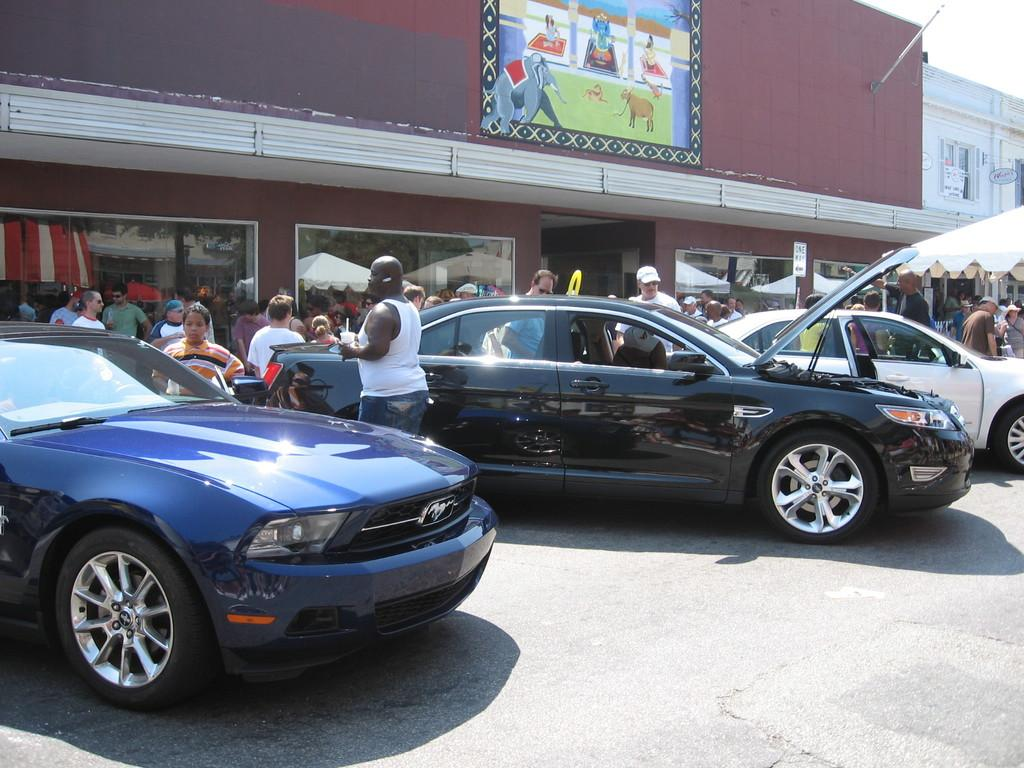What can be seen in the image that is used for transportation? There are vehicles parked in the image. What are the people behind the vehicles doing? There are people standing behind the vehicles. What can be seen in the distance in the image? There is a building and a board in the background of the image. What is visible above the vehicles and people in the image? The sky is visible in the background of the image. What advertisement can be seen on the vehicles in the image? There is no advertisement visible on the vehicles in the image. What nation or organization do the people in the image represent? The image does not provide any information about the nationality or affiliation of the people in the image. 